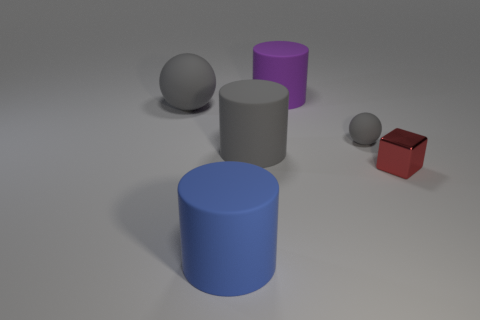How many other things are the same material as the tiny red cube?
Your answer should be very brief. 0. Does the big ball left of the red metal object have the same material as the large cylinder in front of the red metallic cube?
Keep it short and to the point. Yes. Is there any other thing that is the same shape as the small red object?
Offer a terse response. No. Do the large gray cylinder and the gray thing on the right side of the purple rubber thing have the same material?
Your response must be concise. Yes. There is a large cylinder behind the sphere on the left side of the big matte cylinder in front of the red shiny thing; what is its color?
Make the answer very short. Purple. There is another object that is the same size as the red object; what is its shape?
Give a very brief answer. Sphere. Do the metallic object that is behind the big blue rubber cylinder and the gray rubber sphere right of the big blue thing have the same size?
Offer a very short reply. Yes. How big is the gray sphere that is left of the blue matte cylinder?
Your answer should be very brief. Large. There is a object that is the same size as the metallic cube; what color is it?
Your response must be concise. Gray. Is the red shiny object the same size as the purple matte cylinder?
Your response must be concise. No. 